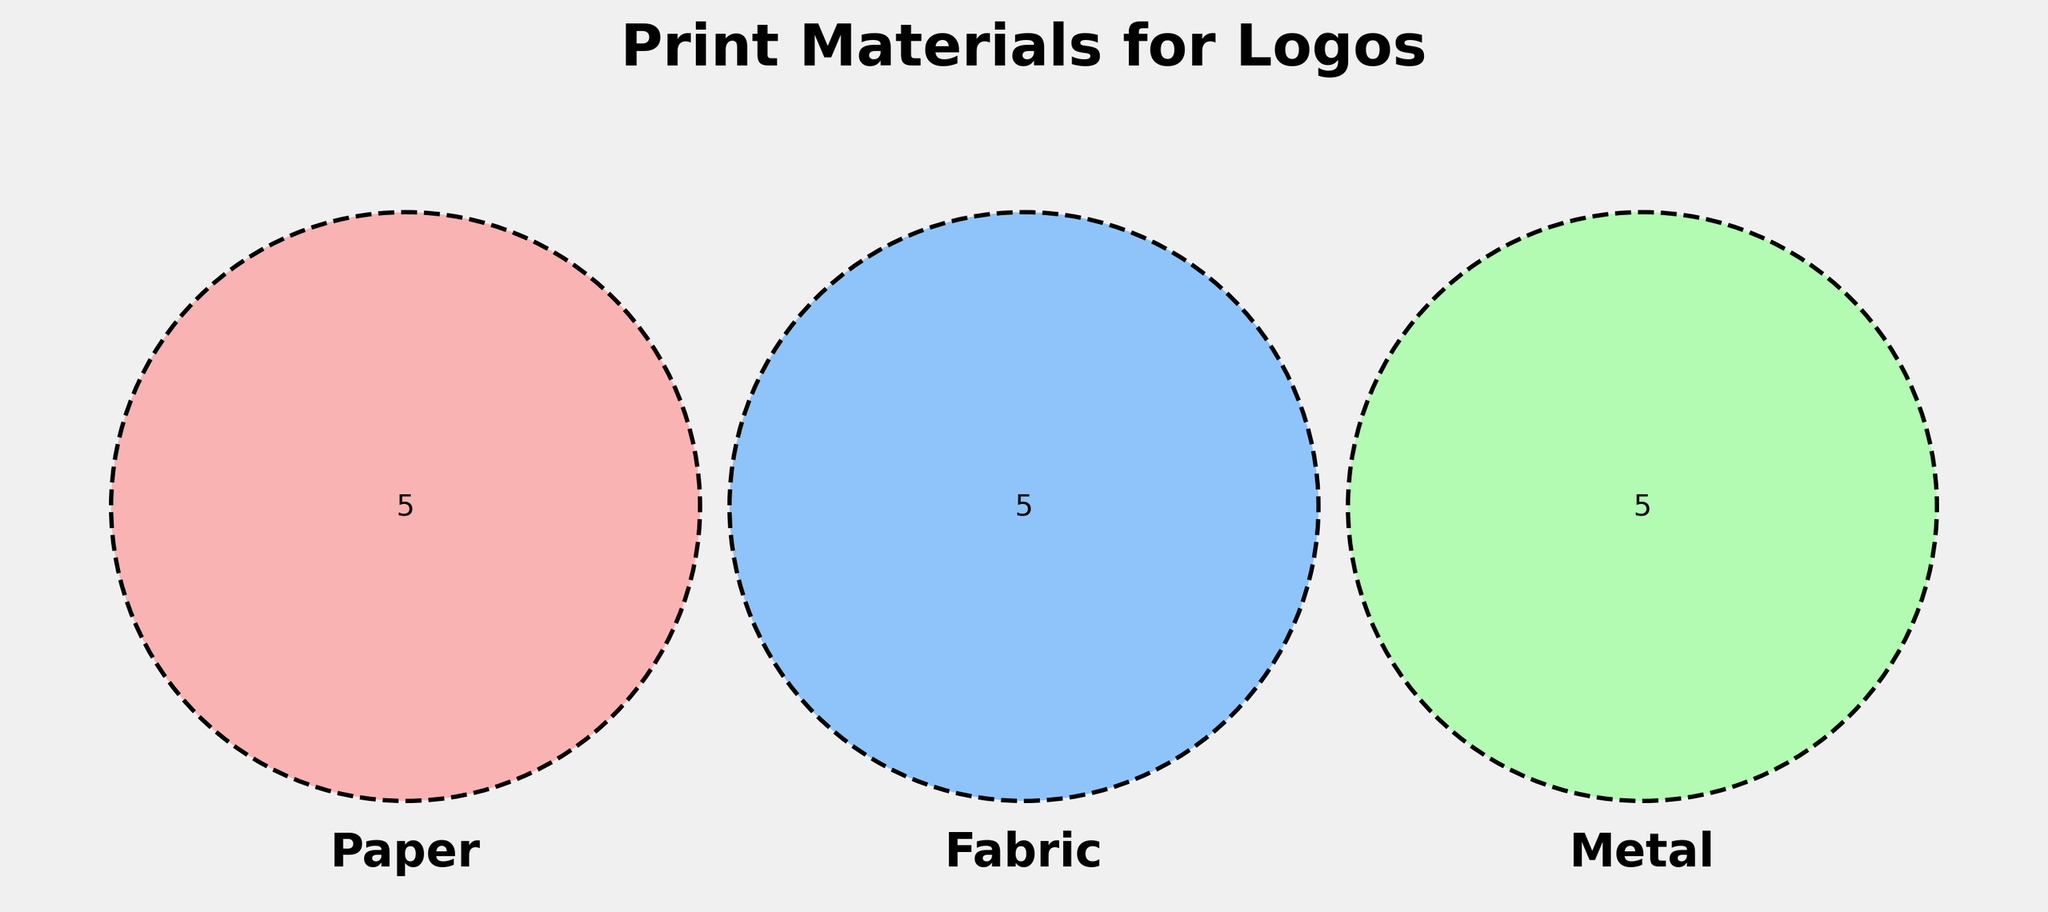What are the three main materials represented in the Venn Diagram? The title and set labels in the Venn Diagram show us the three main materials represented.
Answer: Paper, Fabric, Metal Which material has "Foil stamping" as a technique? By looking at the subset of techniques within the Venn Diagram for each material, we can see that "Foil stamping" falls under the Paper category.
Answer: Paper What technique is used across both Fabric and Metal but not Paper? By examining the overlapping areas between the Fabric and Metal sets, and excluding the overlap with Paper, we identify that there are no techniques shared between only Fabric and Metal sets in this specific diagram.
Answer: None How many techniques are unique to Fabric? Counting the single elements within the Fabric circle that do not overlap with either of the other circles provides the number of unique Fabric techniques.
Answer: 5 Which materials include "Laser marking"? By looking at the areas marked with "Laser marking," we see it falls under the Metal category.
Answer: Metal Is "Embossing" shared by Paper and Fabric materials? Analyzing the overlapping area between Paper and Fabric circles and noting the individual elements indicates that "Embossing" is not shared by Paper and Fabric materials.
Answer: No Which set of materials has the greatest number of unique techniques? Comparing the individual elements within each circle indicates that Paper has 4, Fabric has 5, and Metal has 4 unique techniques. Thus, Fabric has the greatest number.
Answer: Fabric How many techniques are shared among all three materials? The central overlapping area in the Venn Diagram indicates the count of techniques shared among all three materials.
Answer: 0 